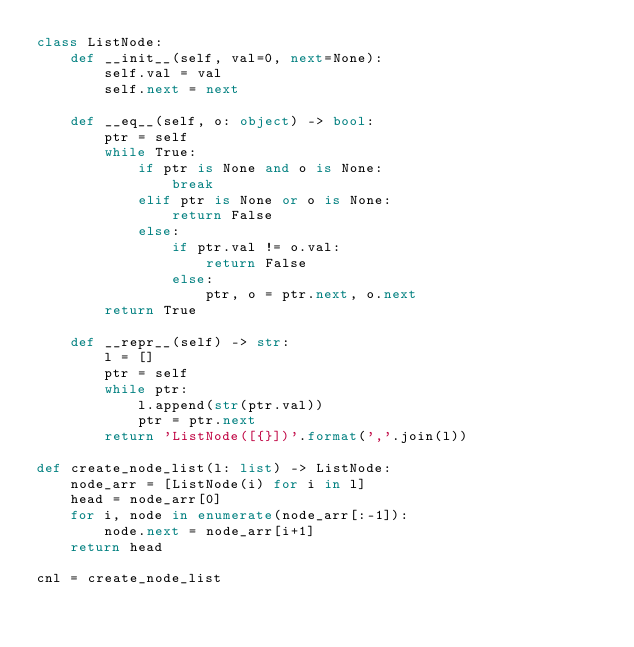<code> <loc_0><loc_0><loc_500><loc_500><_Python_>class ListNode:
    def __init__(self, val=0, next=None):
        self.val = val
        self.next = next

    def __eq__(self, o: object) -> bool:
        ptr = self
        while True:
            if ptr is None and o is None:
                break
            elif ptr is None or o is None:
                return False
            else:
                if ptr.val != o.val:
                    return False
                else:
                    ptr, o = ptr.next, o.next
        return True

    def __repr__(self) -> str:
        l = []
        ptr = self
        while ptr:
            l.append(str(ptr.val))
            ptr = ptr.next
        return 'ListNode([{}])'.format(','.join(l))

def create_node_list(l: list) -> ListNode:
    node_arr = [ListNode(i) for i in l]
    head = node_arr[0]
    for i, node in enumerate(node_arr[:-1]):
        node.next = node_arr[i+1]
    return head

cnl = create_node_list</code> 